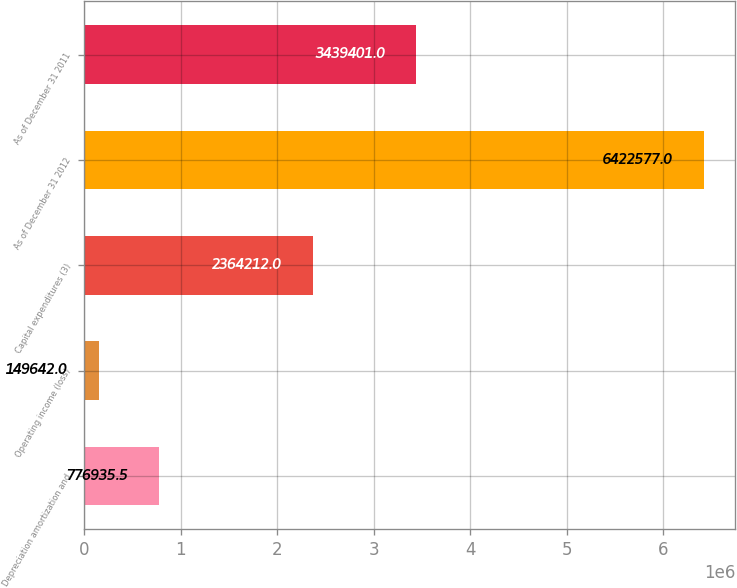Convert chart to OTSL. <chart><loc_0><loc_0><loc_500><loc_500><bar_chart><fcel>Depreciation amortization and<fcel>Operating income (loss)<fcel>Capital expenditures (3)<fcel>As of December 31 2012<fcel>As of December 31 2011<nl><fcel>776936<fcel>149642<fcel>2.36421e+06<fcel>6.42258e+06<fcel>3.4394e+06<nl></chart> 